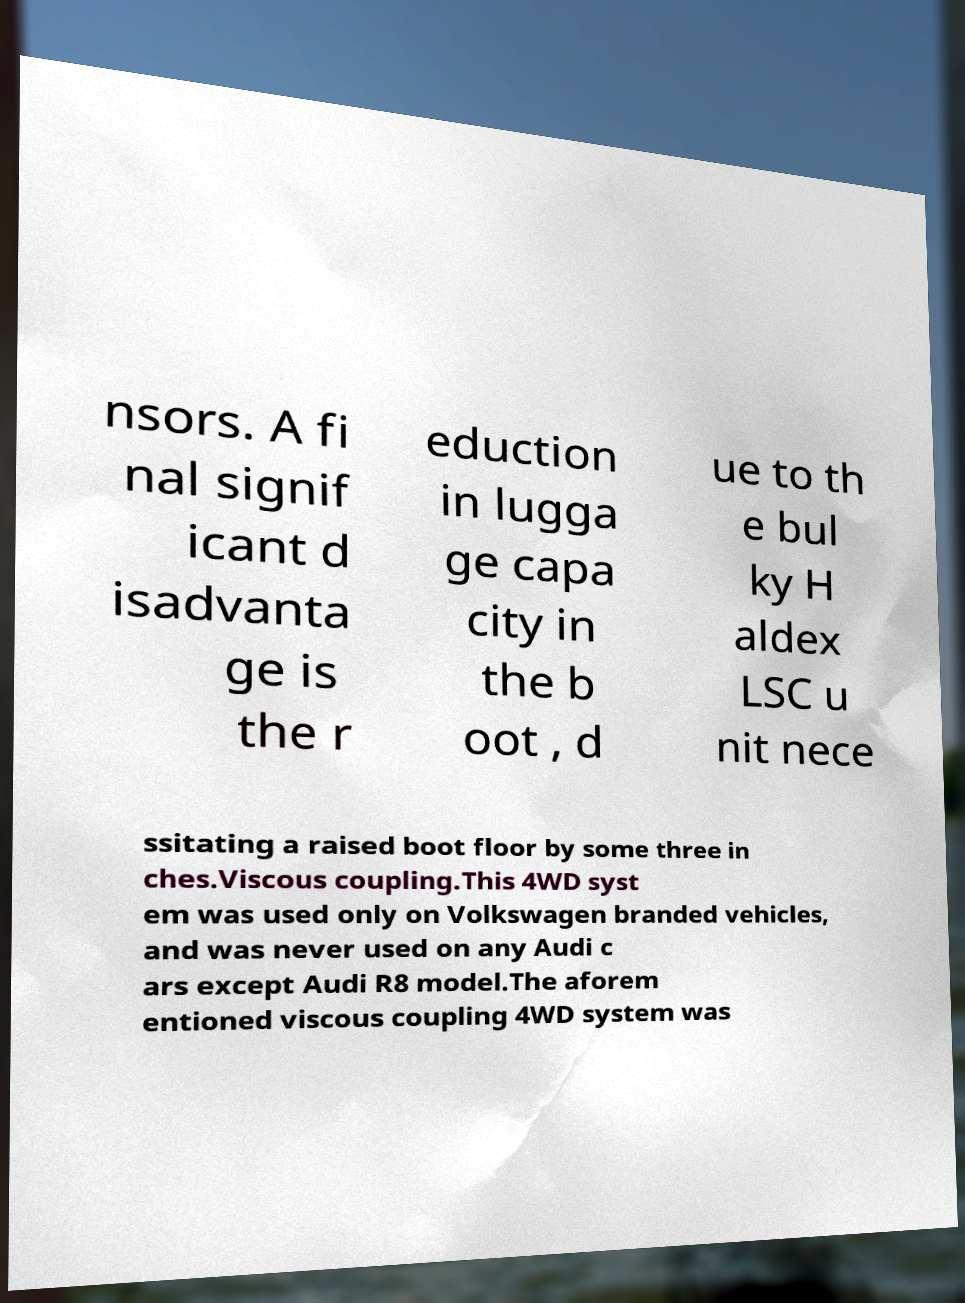What messages or text are displayed in this image? I need them in a readable, typed format. nsors. A fi nal signif icant d isadvanta ge is the r eduction in lugga ge capa city in the b oot , d ue to th e bul ky H aldex LSC u nit nece ssitating a raised boot floor by some three in ches.Viscous coupling.This 4WD syst em was used only on Volkswagen branded vehicles, and was never used on any Audi c ars except Audi R8 model.The aforem entioned viscous coupling 4WD system was 